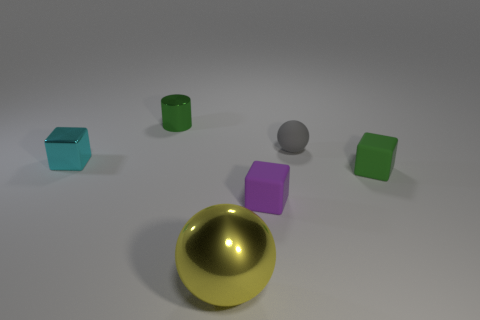Are there any other things that have the same size as the gray ball? When closely examining the image, it appears that the purple cube may be a close match in size to the gray ball, though an exact comparison cannot be made without specific measurements. The other objects—the green cylinders and the blue cube—display noticeable size differences when assessed visually. 